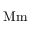Convert formula to latex. <formula><loc_0><loc_0><loc_500><loc_500>{ M m }</formula> 